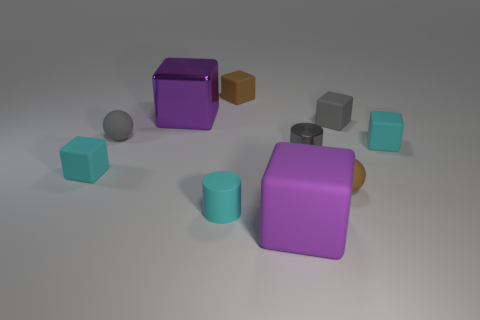There is a purple thing that is made of the same material as the brown cube; what size is it?
Your answer should be very brief. Large. What number of objects are rubber blocks to the left of the small gray cylinder or small purple rubber cylinders?
Keep it short and to the point. 3. There is a large rubber thing that is in front of the tiny gray cylinder; does it have the same color as the large metallic thing?
Ensure brevity in your answer.  Yes. There is a purple metal thing that is the same shape as the big purple rubber object; what is its size?
Make the answer very short. Large. There is a rubber sphere to the right of the tiny thing that is behind the tiny gray matte object right of the large metallic cube; what color is it?
Your answer should be very brief. Brown. Do the brown cube and the small gray cylinder have the same material?
Your answer should be very brief. No. There is a big purple block behind the gray rubber thing to the right of the small gray cylinder; is there a gray ball to the left of it?
Offer a terse response. Yes. Do the large shiny thing and the large rubber block have the same color?
Make the answer very short. Yes. Are there fewer gray things than small cylinders?
Offer a very short reply. No. Is the material of the purple object to the right of the cyan rubber cylinder the same as the tiny gray object that is to the right of the small metallic thing?
Provide a succinct answer. Yes. 